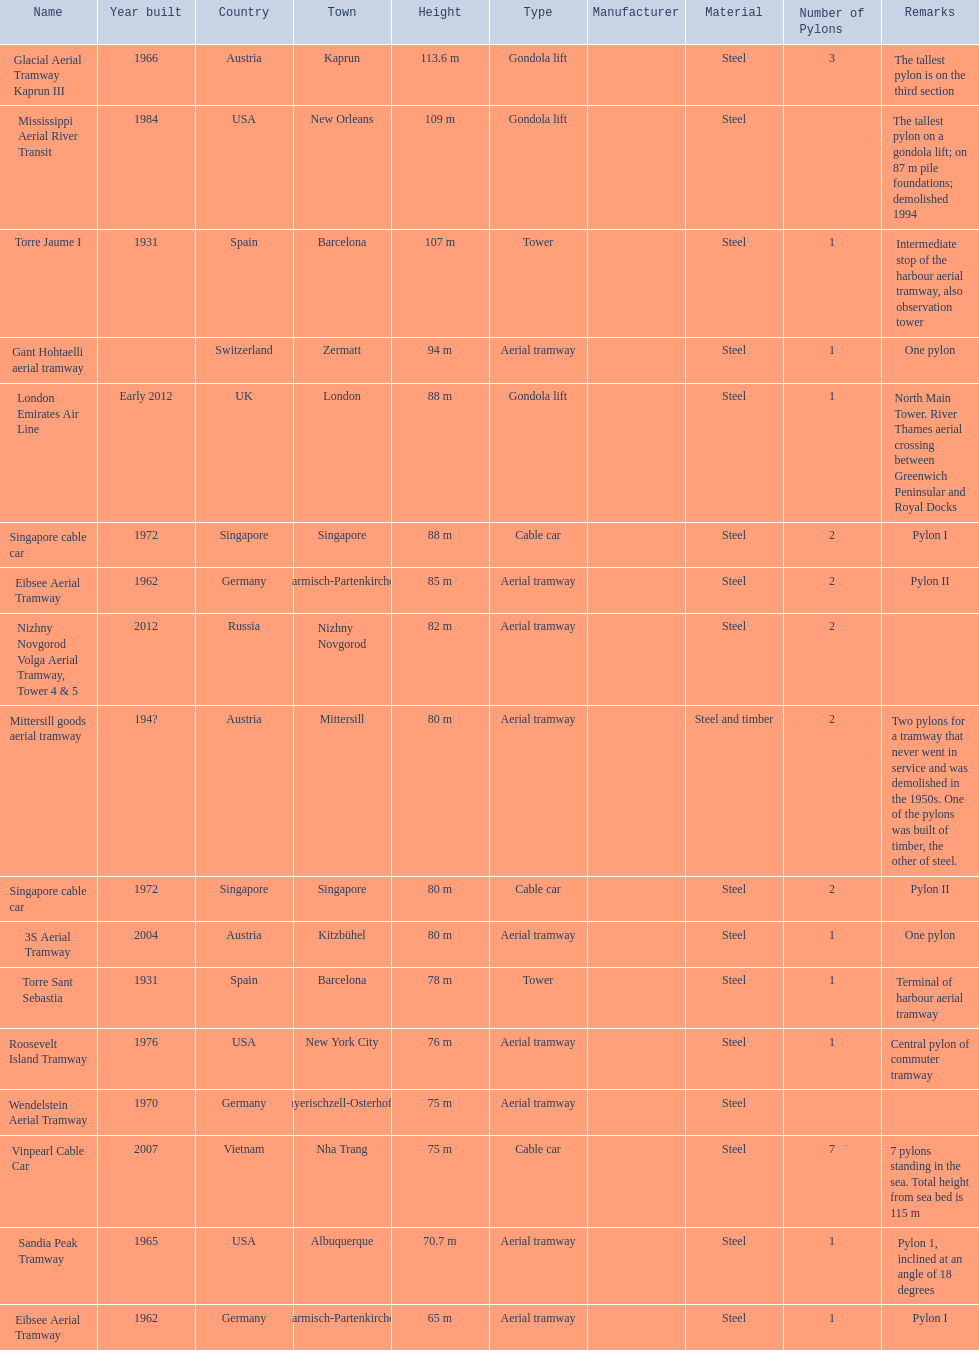How many aerial lift pylon's on the list are located in the usa? Mississippi Aerial River Transit, Roosevelt Island Tramway, Sandia Peak Tramway. Of the pylon's located in the usa how many were built after 1970? Mississippi Aerial River Transit, Roosevelt Island Tramway. Of the pylon's built after 1970 which is the tallest pylon on a gondola lift? Mississippi Aerial River Transit. How many meters is the tallest pylon on a gondola lift? 109 m. 